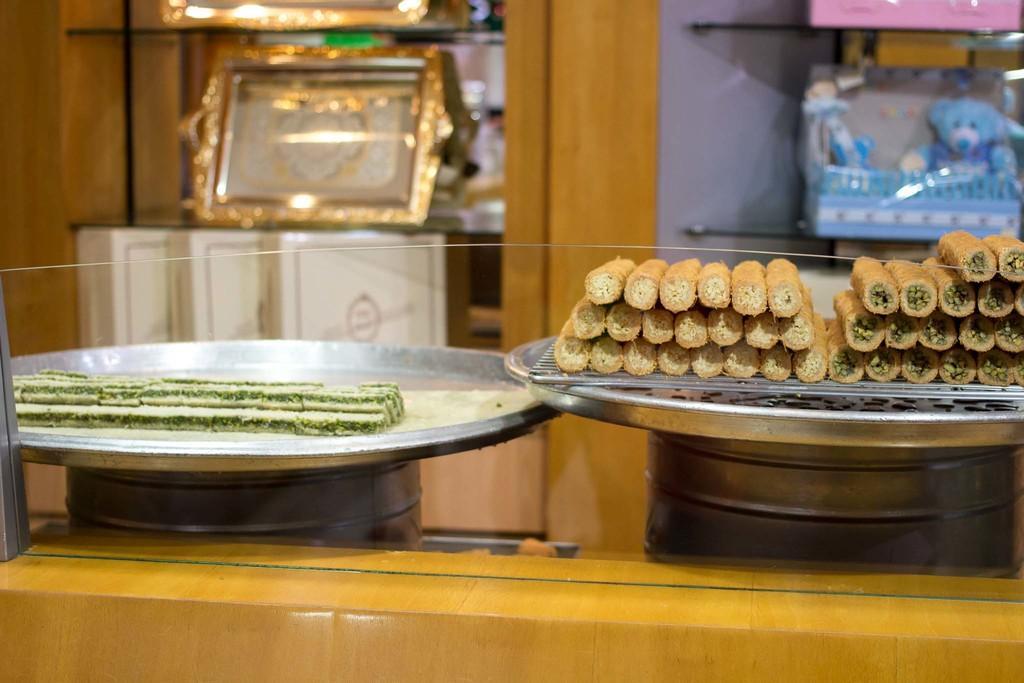In one or two sentences, can you explain what this image depicts? In this image, we can see some food items in plates are placed on some objects. We can also see some glass and wood at the bottom. We can also see some shelves with objects. 